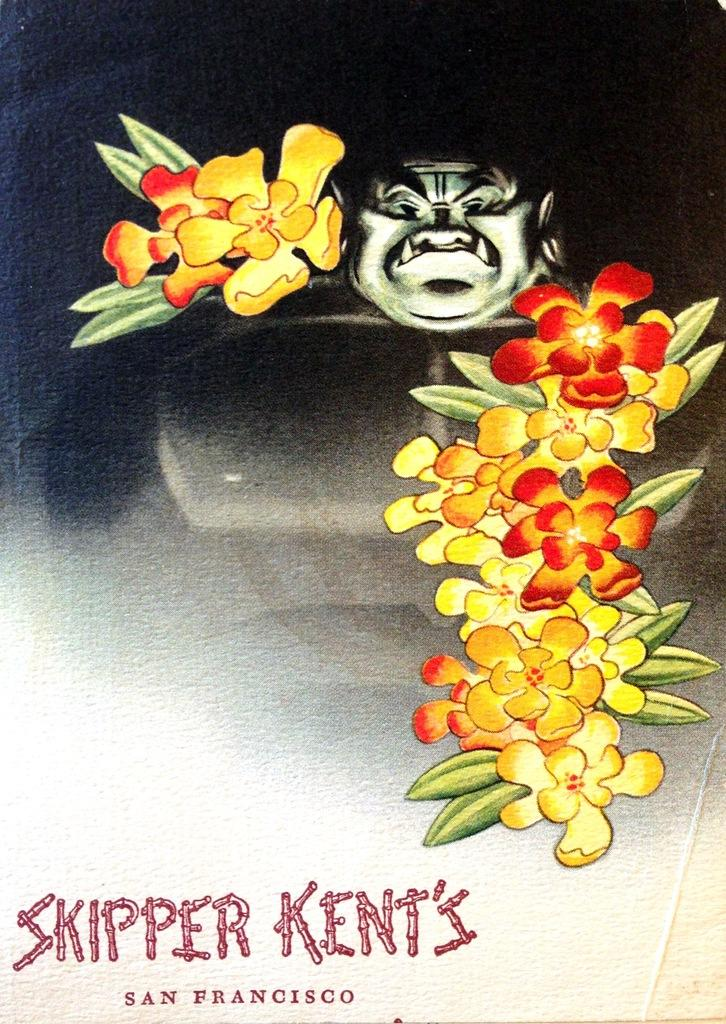What is the main subject of the image? There is a depiction of a person in the center of the image. What other elements can be seen in the image? There are flowers in the image. Is there any text present in the image? Yes, there is text printed at the bottom of the image. How many kittens are playing with the transport in the image? There are no kittens or transport present in the image. What is the color of the moon in the image? There is no moon present in the image. 